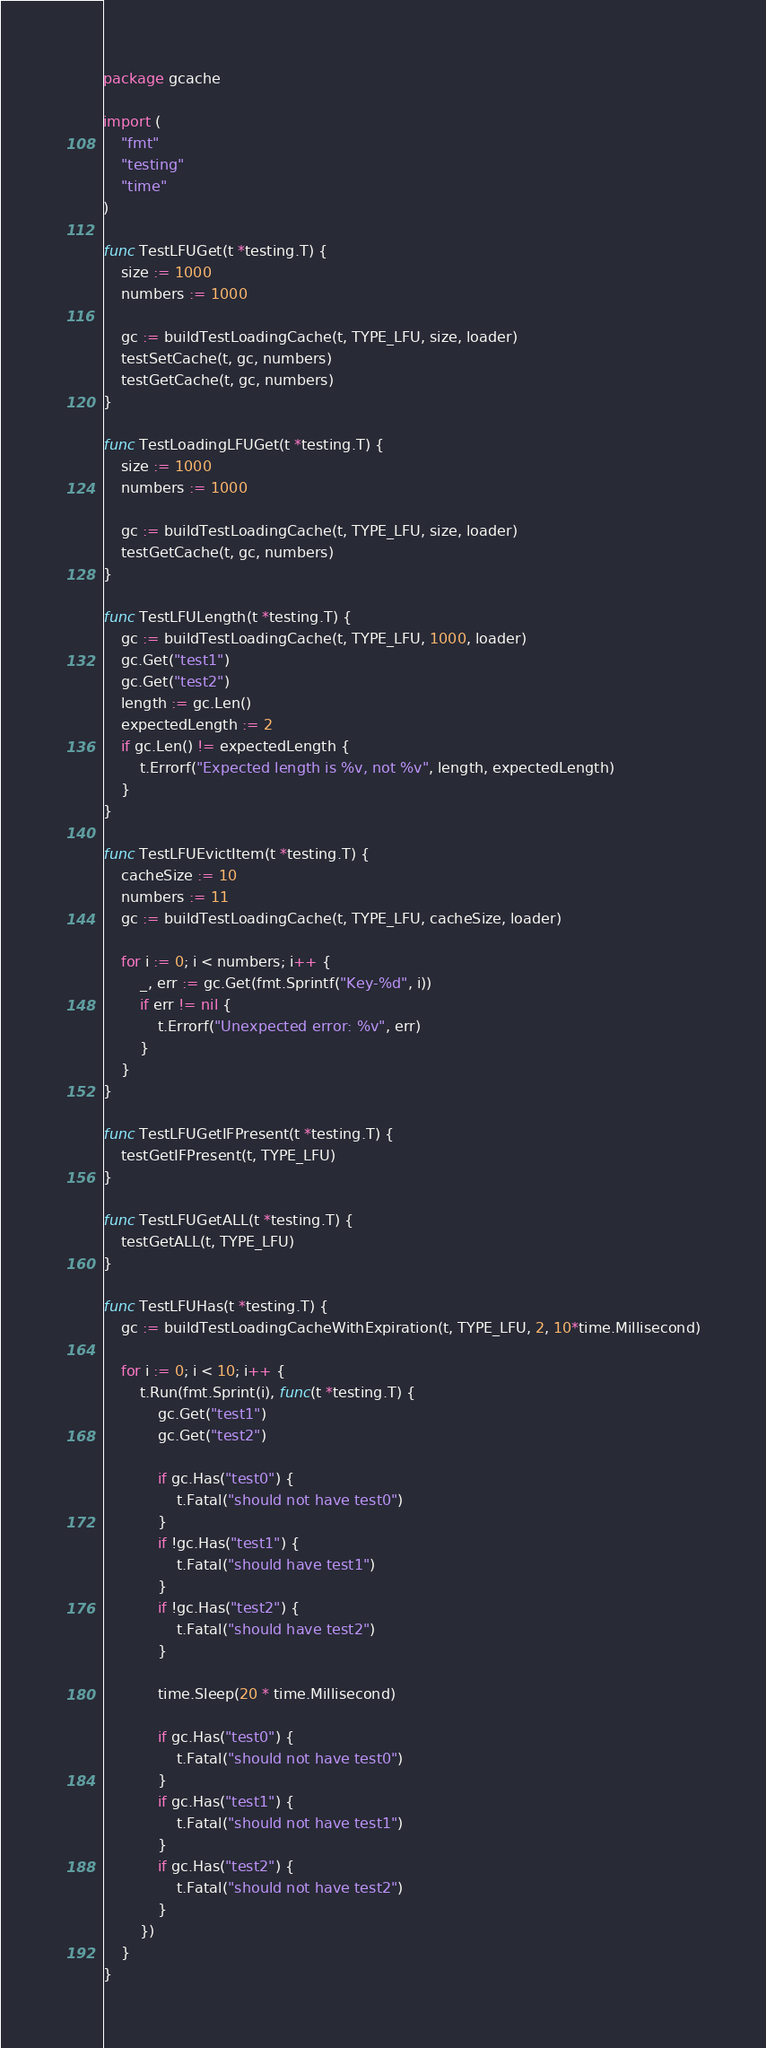Convert code to text. <code><loc_0><loc_0><loc_500><loc_500><_Go_>package gcache

import (
	"fmt"
	"testing"
	"time"
)

func TestLFUGet(t *testing.T) {
	size := 1000
	numbers := 1000

	gc := buildTestLoadingCache(t, TYPE_LFU, size, loader)
	testSetCache(t, gc, numbers)
	testGetCache(t, gc, numbers)
}

func TestLoadingLFUGet(t *testing.T) {
	size := 1000
	numbers := 1000

	gc := buildTestLoadingCache(t, TYPE_LFU, size, loader)
	testGetCache(t, gc, numbers)
}

func TestLFULength(t *testing.T) {
	gc := buildTestLoadingCache(t, TYPE_LFU, 1000, loader)
	gc.Get("test1")
	gc.Get("test2")
	length := gc.Len()
	expectedLength := 2
	if gc.Len() != expectedLength {
		t.Errorf("Expected length is %v, not %v", length, expectedLength)
	}
}

func TestLFUEvictItem(t *testing.T) {
	cacheSize := 10
	numbers := 11
	gc := buildTestLoadingCache(t, TYPE_LFU, cacheSize, loader)

	for i := 0; i < numbers; i++ {
		_, err := gc.Get(fmt.Sprintf("Key-%d", i))
		if err != nil {
			t.Errorf("Unexpected error: %v", err)
		}
	}
}

func TestLFUGetIFPresent(t *testing.T) {
	testGetIFPresent(t, TYPE_LFU)
}

func TestLFUGetALL(t *testing.T) {
	testGetALL(t, TYPE_LFU)
}

func TestLFUHas(t *testing.T) {
	gc := buildTestLoadingCacheWithExpiration(t, TYPE_LFU, 2, 10*time.Millisecond)

	for i := 0; i < 10; i++ {
		t.Run(fmt.Sprint(i), func(t *testing.T) {
			gc.Get("test1")
			gc.Get("test2")

			if gc.Has("test0") {
				t.Fatal("should not have test0")
			}
			if !gc.Has("test1") {
				t.Fatal("should have test1")
			}
			if !gc.Has("test2") {
				t.Fatal("should have test2")
			}

			time.Sleep(20 * time.Millisecond)

			if gc.Has("test0") {
				t.Fatal("should not have test0")
			}
			if gc.Has("test1") {
				t.Fatal("should not have test1")
			}
			if gc.Has("test2") {
				t.Fatal("should not have test2")
			}
		})
	}
}
</code> 